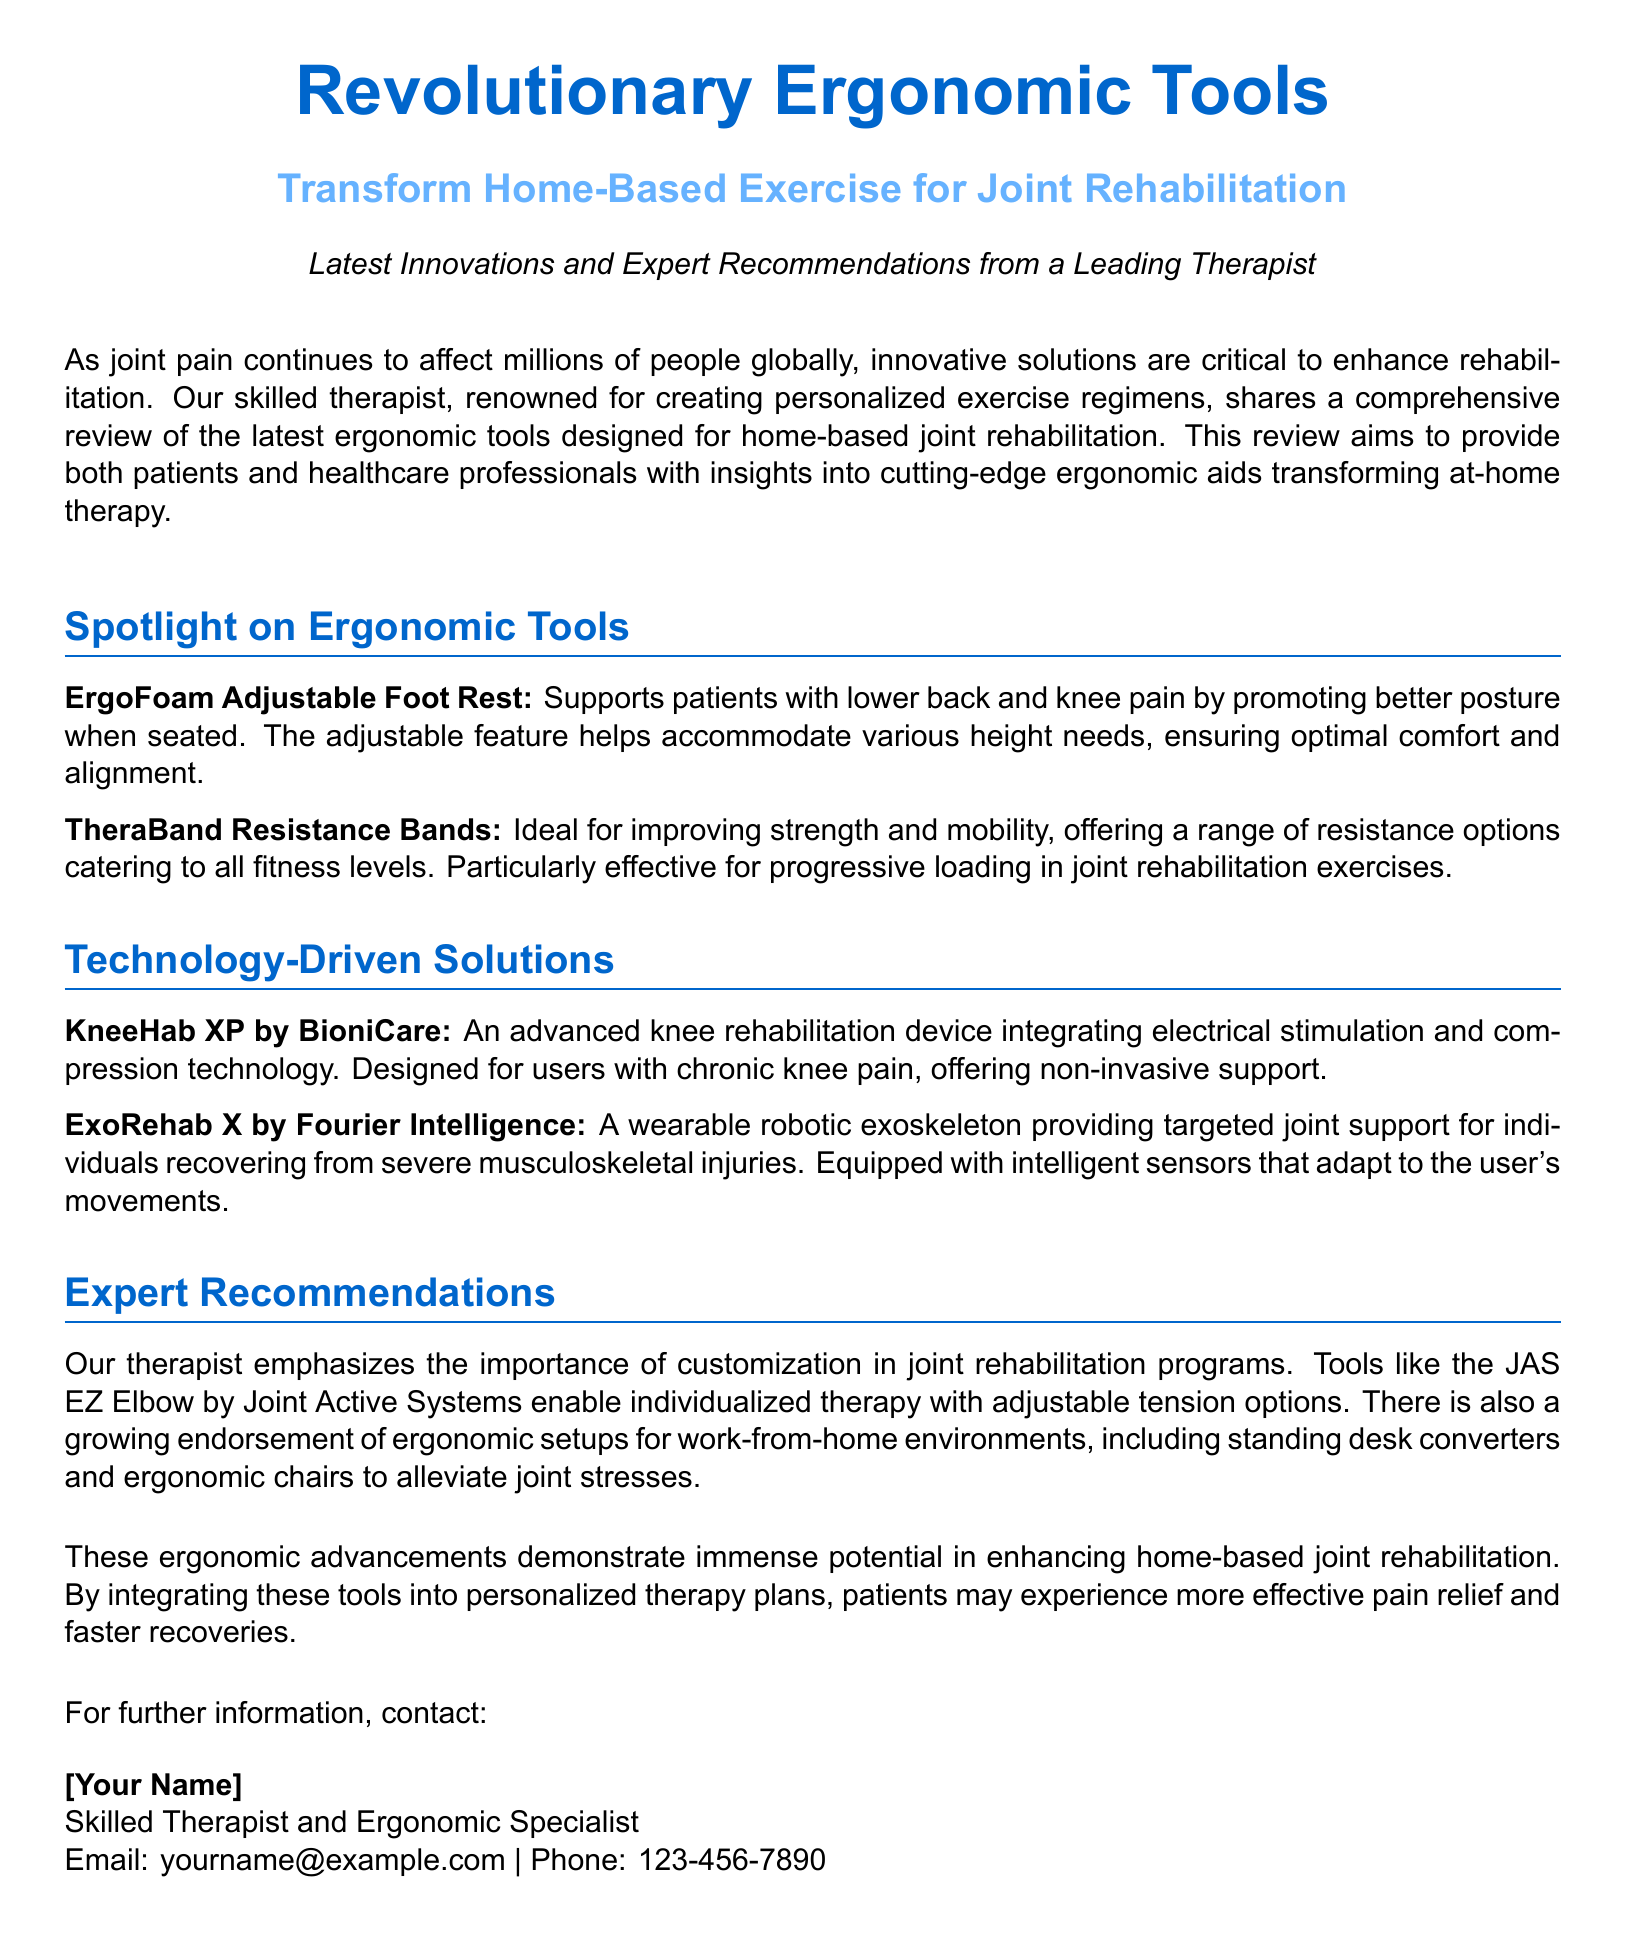What is the main focus of the press release? The press release focuses on innovative ergonomic tools supporting home-based exercise for joint rehabilitation.
Answer: innovative ergonomic tools supporting home-based exercise for joint rehabilitation Who authored the comprehensive review? The review is authored by a skilled therapist experienced in developing personalized exercise regimens.
Answer: a skilled therapist What type of posture does the ErgoFoam Adjustable Foot Rest promote? The ErgoFoam Adjustable Foot Rest promotes better posture when seated.
Answer: better posture What does the KneeHab XP by BioniCare integrate? The KneeHab XP integrates electrical stimulation and compression technology.
Answer: electrical stimulation and compression technology Which ergonomic tool applies adjustable tension options? The JAS EZ Elbow by Joint Active Systems applies adjustable tension options.
Answer: JAS EZ Elbow by Joint Active Systems What are TheraBand Resistance Bands particularly effective for? TheraBand Resistance Bands are particularly effective for progressive loading in joint rehabilitation exercises.
Answer: progressive loading How are the ergonomic tools intended to affect pain relief? The tools are intended to enhance home-based joint rehabilitation and improve pain relief.
Answer: enhance home-based joint rehabilitation and improve pain relief What does the press release emphasize as important in joint rehabilitation programs? The press release emphasizes the importance of customization in joint rehabilitation programs.
Answer: customization What type of document is this? This document is a press release.
Answer: press release 